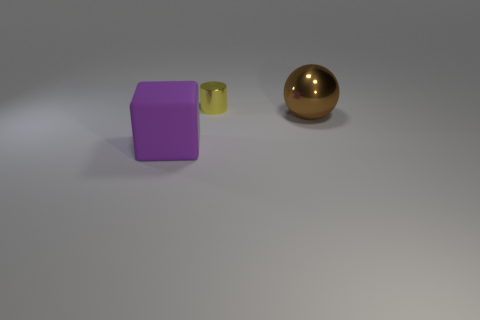How many other objects are the same material as the big cube?
Give a very brief answer. 0. What number of other things are there of the same color as the tiny shiny thing?
Offer a terse response. 0. Is there any other thing that is the same size as the yellow object?
Your answer should be compact. No. There is a matte cube that is to the left of the large brown metallic ball; how big is it?
Give a very brief answer. Large. Are there any big rubber blocks of the same color as the cylinder?
Ensure brevity in your answer.  No. Are there any big purple rubber objects that are on the left side of the big thing to the right of the tiny yellow metallic cylinder?
Your response must be concise. Yes. There is a yellow cylinder; does it have the same size as the brown metallic thing that is to the right of the small yellow shiny cylinder?
Provide a succinct answer. No. There is a object that is in front of the big thing behind the big purple matte thing; are there any big metallic things that are in front of it?
Your answer should be compact. No. There is a cylinder on the left side of the brown shiny ball; what is its material?
Make the answer very short. Metal. Does the metallic ball have the same size as the yellow metallic cylinder?
Make the answer very short. No. 